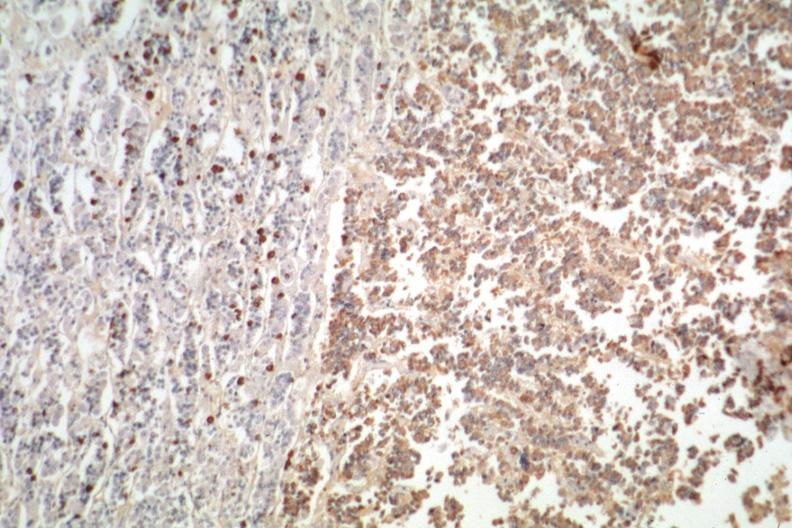do peritoneal fluid stain is positive?
Answer the question using a single word or phrase. No 